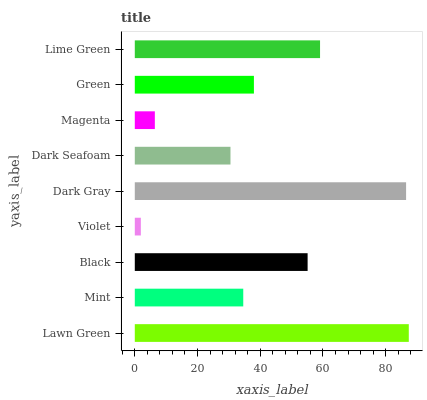Is Violet the minimum?
Answer yes or no. Yes. Is Lawn Green the maximum?
Answer yes or no. Yes. Is Mint the minimum?
Answer yes or no. No. Is Mint the maximum?
Answer yes or no. No. Is Lawn Green greater than Mint?
Answer yes or no. Yes. Is Mint less than Lawn Green?
Answer yes or no. Yes. Is Mint greater than Lawn Green?
Answer yes or no. No. Is Lawn Green less than Mint?
Answer yes or no. No. Is Green the high median?
Answer yes or no. Yes. Is Green the low median?
Answer yes or no. Yes. Is Magenta the high median?
Answer yes or no. No. Is Lime Green the low median?
Answer yes or no. No. 